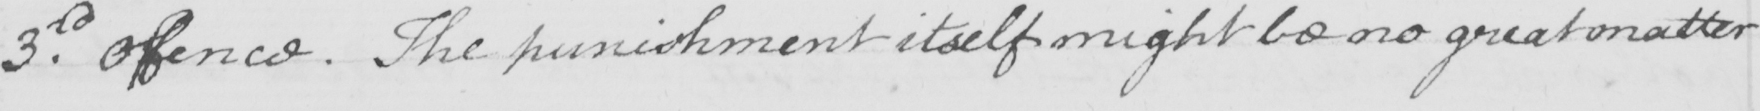Can you tell me what this handwritten text says? 3rd . offence . The punishment itself might be no great matter 